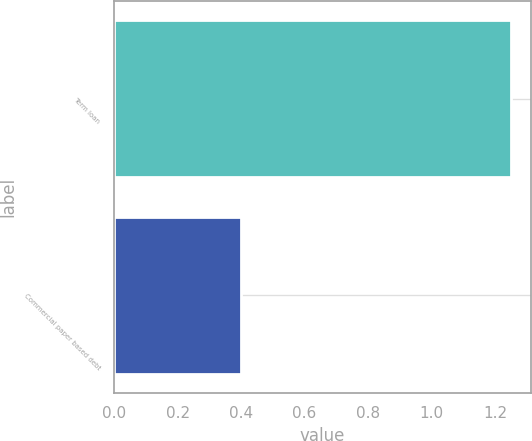Convert chart to OTSL. <chart><loc_0><loc_0><loc_500><loc_500><bar_chart><fcel>Term loan<fcel>Commercial paper based debt<nl><fcel>1.25<fcel>0.4<nl></chart> 